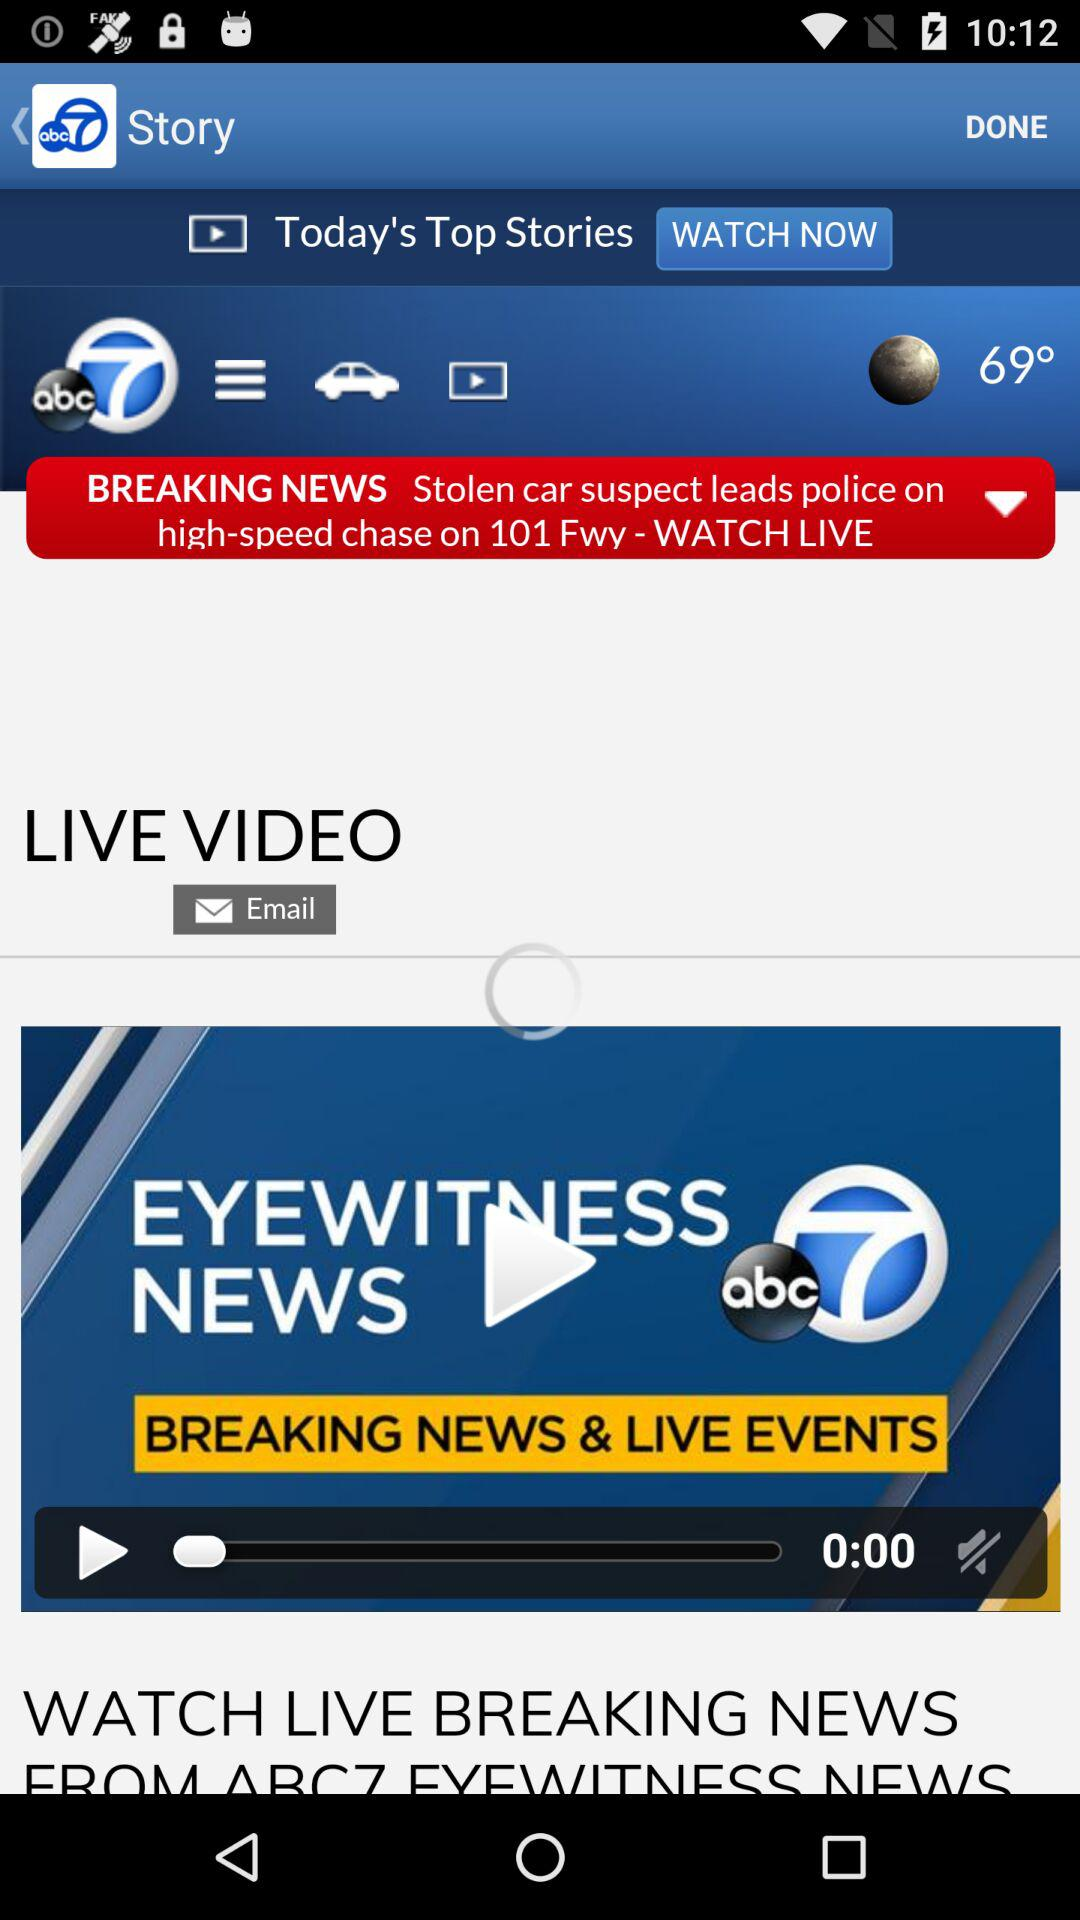What is the temperature? The temperature is 69°. 